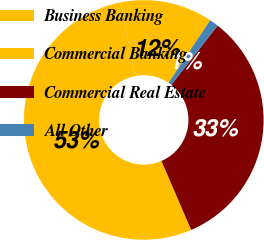<chart> <loc_0><loc_0><loc_500><loc_500><pie_chart><fcel>Business Banking<fcel>Commercial Banking<fcel>Commercial Real Estate<fcel>All Other<nl><fcel>12.46%<fcel>53.37%<fcel>32.95%<fcel>1.22%<nl></chart> 